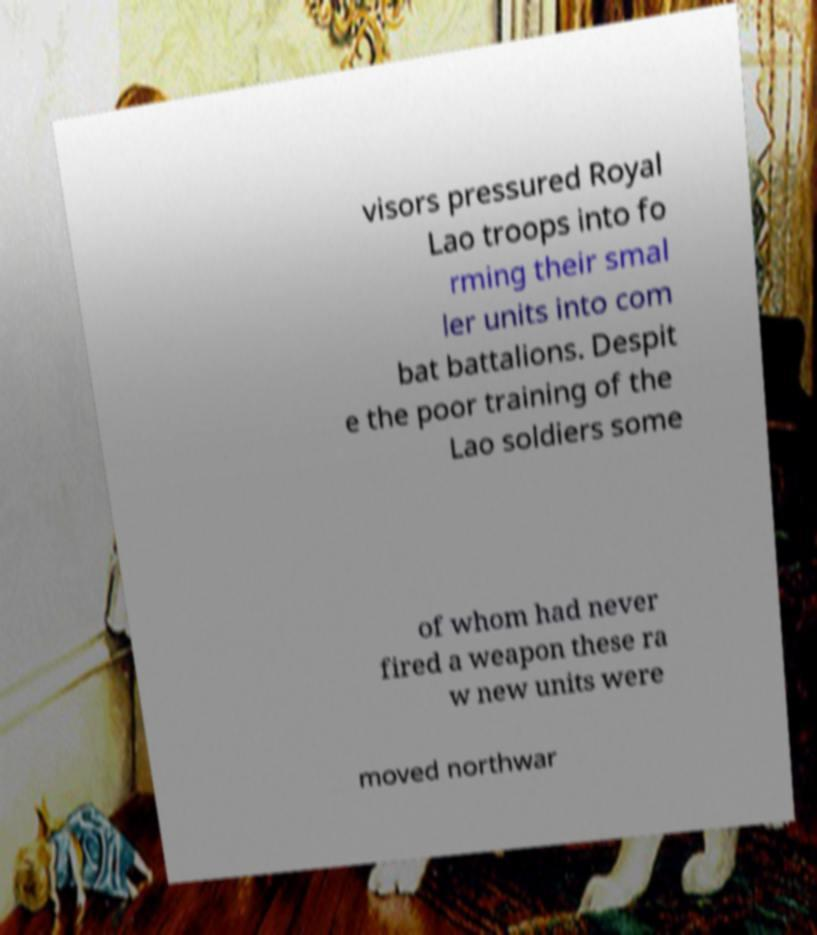For documentation purposes, I need the text within this image transcribed. Could you provide that? visors pressured Royal Lao troops into fo rming their smal ler units into com bat battalions. Despit e the poor training of the Lao soldiers some of whom had never fired a weapon these ra w new units were moved northwar 